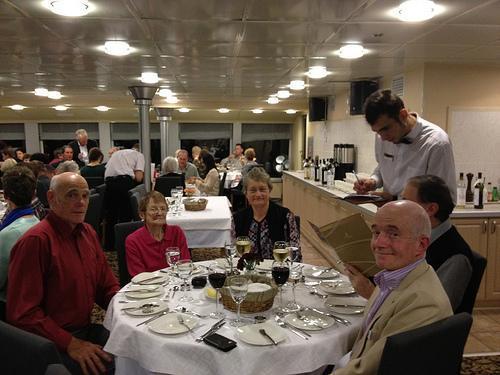How many people are sitting at the table closest to the camera?
Give a very brief answer. 5. How many men are sitting at the first table from the camera?
Give a very brief answer. 3. How many women does the first table from the camera have?
Give a very brief answer. 2. How many people are standing?
Give a very brief answer. 3. How many windows are pictured?
Give a very brief answer. 5. 